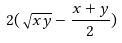Convert formula to latex. <formula><loc_0><loc_0><loc_500><loc_500>2 ( \sqrt { x y } - \frac { x + y } { 2 } )</formula> 